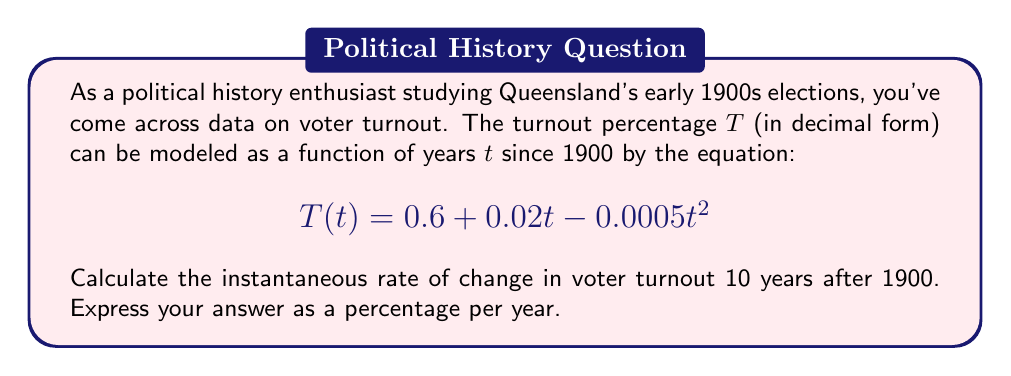Show me your answer to this math problem. To solve this problem, we need to follow these steps:

1) The instantaneous rate of change is given by the derivative of the function $T(t)$ at the point $t=10$.

2) First, let's find the derivative of $T(t)$:
   
   $$\frac{d}{dt}T(t) = \frac{d}{dt}(0.6 + 0.02t - 0.0005t^2)$$
   $$T'(t) = 0.02 - 0.001t$$

3) Now, we need to evaluate this derivative at $t=10$:
   
   $$T'(10) = 0.02 - 0.001(10)$$
   $$T'(10) = 0.02 - 0.01$$
   $$T'(10) = 0.01$$

4) This result is in decimal form, representing the change in turnout per year. To convert it to a percentage, we multiply by 100:

   $$0.01 \times 100 = 1\%$$

Thus, 10 years after 1900, the instantaneous rate of change in voter turnout was 1% per year.
Answer: 1% per year 